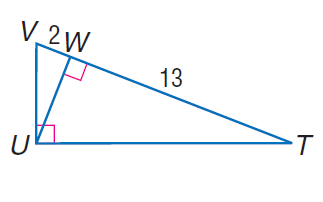Answer the mathemtical geometry problem and directly provide the correct option letter.
Question: Find the measure of the altitude drawn to the hypotenuse.
Choices: A: \sqrt { 2 } B: \sqrt { 6.5 } C: \sqrt { 13 } D: \sqrt { 26 } D 